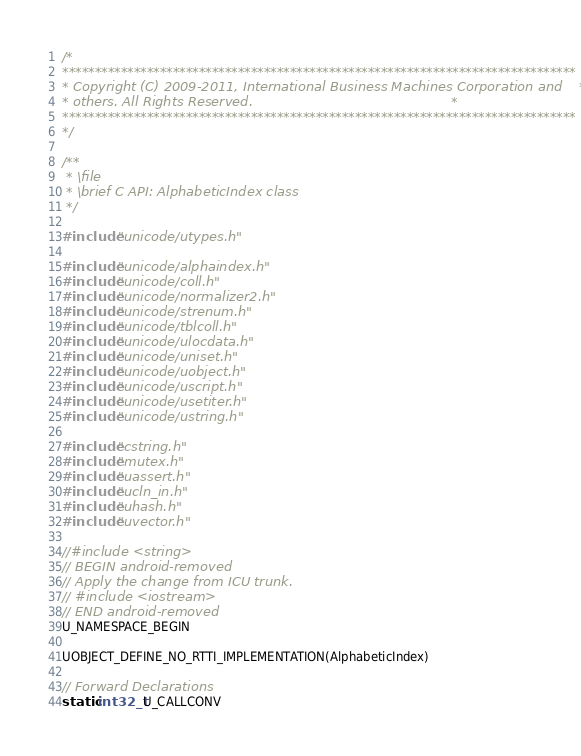Convert code to text. <code><loc_0><loc_0><loc_500><loc_500><_C++_>/*
*******************************************************************************
* Copyright (C) 2009-2011, International Business Machines Corporation and    *
* others. All Rights Reserved.                                                *
*******************************************************************************
*/

/**
 * \file
 * \brief C API: AlphabeticIndex class
 */

#include "unicode/utypes.h"

#include "unicode/alphaindex.h"
#include "unicode/coll.h"
#include "unicode/normalizer2.h"
#include "unicode/strenum.h"
#include "unicode/tblcoll.h"
#include "unicode/ulocdata.h"
#include "unicode/uniset.h"
#include "unicode/uobject.h"
#include "unicode/uscript.h"
#include "unicode/usetiter.h"
#include "unicode/ustring.h"

#include "cstring.h"
#include "mutex.h"
#include "uassert.h"
#include "ucln_in.h"
#include "uhash.h"
#include "uvector.h"

//#include <string>
// BEGIN android-removed
// Apply the change from ICU trunk.
// #include <iostream>
// END android-removed
U_NAMESPACE_BEGIN

UOBJECT_DEFINE_NO_RTTI_IMPLEMENTATION(AlphabeticIndex)

// Forward Declarations
static int32_t U_CALLCONV</code> 